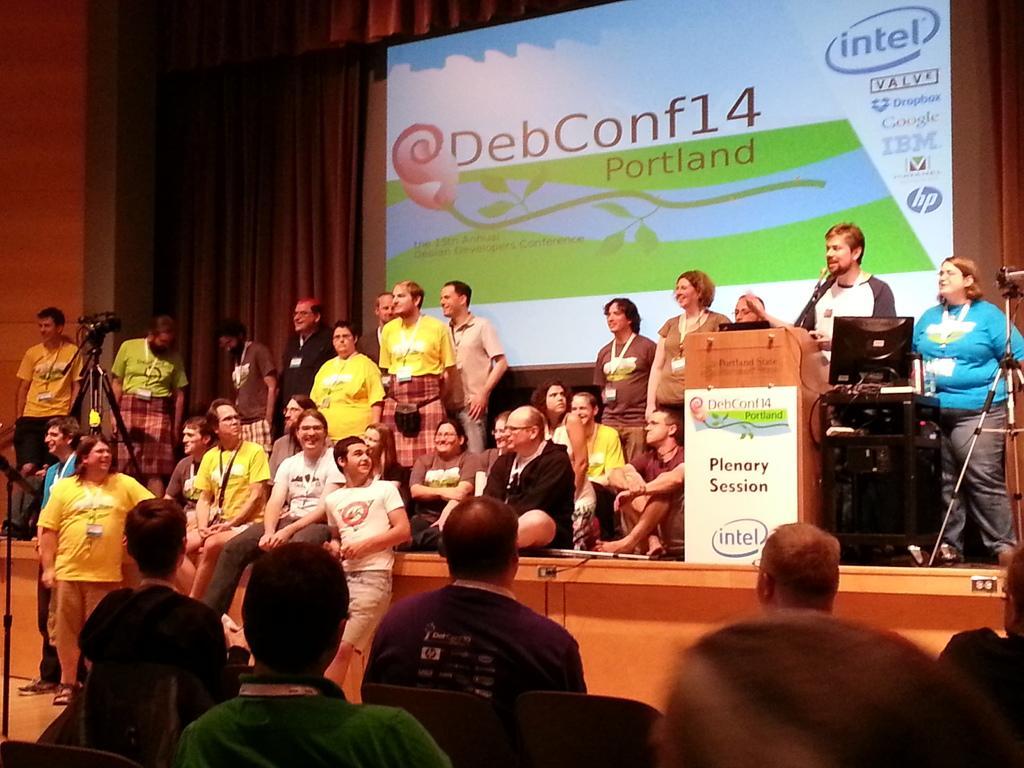Describe this image in one or two sentences. As we can see in the image there is a wall, curtains, screen, few people here and there, laptop and there is camera. 